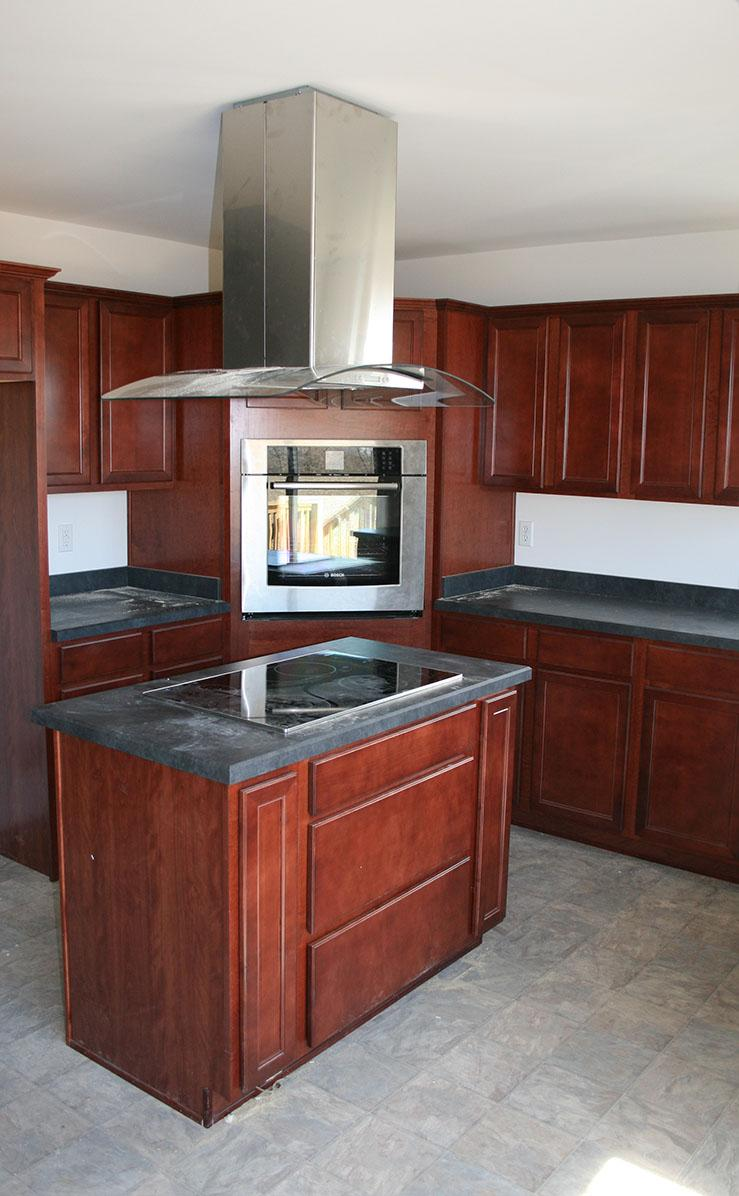Question: what is this of?
Choices:
A. A kitchen.
B. A girl.
C. A newsstand.
D. A house.
Answer with the letter. Answer: A Question: what kind of cabinets?
Choices:
A. Birch.
B. Laminate.
C. Plywood.
D. Cherry oak wood cabinets.
Answer with the letter. Answer: D Question: who is in the photo?
Choices:
A. My husband.
B. A group of students.
C. None.
D. An actor.
Answer with the letter. Answer: C Question: what kind of kitchen is it?
Choices:
A. Old.
B. Wood.
C. Toy.
D. Modern.
Answer with the letter. Answer: D Question: what material is the vent?
Choices:
A. Rust.
B. Dust.
C. Metal.
D. Fabric.
Answer with the letter. Answer: C Question: where is this taken?
Choices:
A. On a patio.
B. On a balcony.
C. In the kitchen of a new home.
D. In the hallway.
Answer with the letter. Answer: C Question: what does the island contain?
Choices:
A. Flowers.
B. Hula dancers.
C. An electric stovetop.
D. Coconuts.
Answer with the letter. Answer: C Question: what kind of wood are the cabinets?
Choices:
A. Oak.
B. Cherry.
C. Pine.
D. Dark wood.
Answer with the letter. Answer: D Question: what kind of wood are the cupboards?
Choices:
A. Light oak.
B. Cherry wood.
C. Dark wood.
D. Fake wood.
Answer with the letter. Answer: C Question: how many outlets are visible?
Choices:
A. Four.
B. Two.
C. One.
D. Three.
Answer with the letter. Answer: B Question: what color are the walls?
Choices:
A. White.
B. Blue.
C. Red.
D. Green.
Answer with the letter. Answer: A Question: how does the kitchen appear?
Choices:
A. Tidy.
B. Well used and cozy.
C. Like a hurricane has been through it.
D. Old-fashioned but serviceable.
Answer with the letter. Answer: A Question: what's on the counters?
Choices:
A. Canned goods.
B. Candy displays.
C. Nothing.
D. Dirty dishes.
Answer with the letter. Answer: C Question: what does the room look like?
Choices:
A. It has white walls.
B. The floor is wood.
C. It has a rectangular shape.
D. It's bare.
Answer with the letter. Answer: D Question: what type of handles can be seen?
Choices:
A. Cabinet handles.
B. None.
C. Door handles.
D. Refrigerator handle.
Answer with the letter. Answer: B 